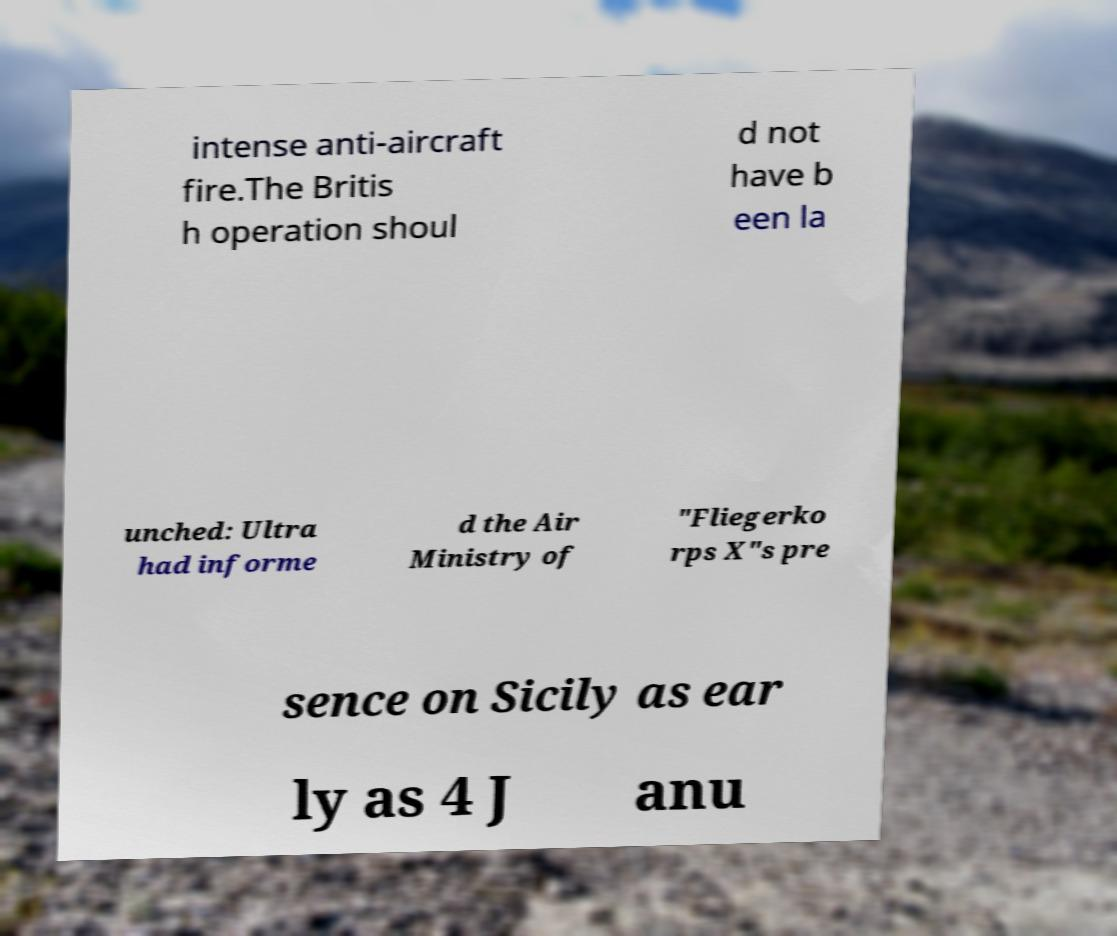Please read and relay the text visible in this image. What does it say? intense anti-aircraft fire.The Britis h operation shoul d not have b een la unched: Ultra had informe d the Air Ministry of "Fliegerko rps X"s pre sence on Sicily as ear ly as 4 J anu 